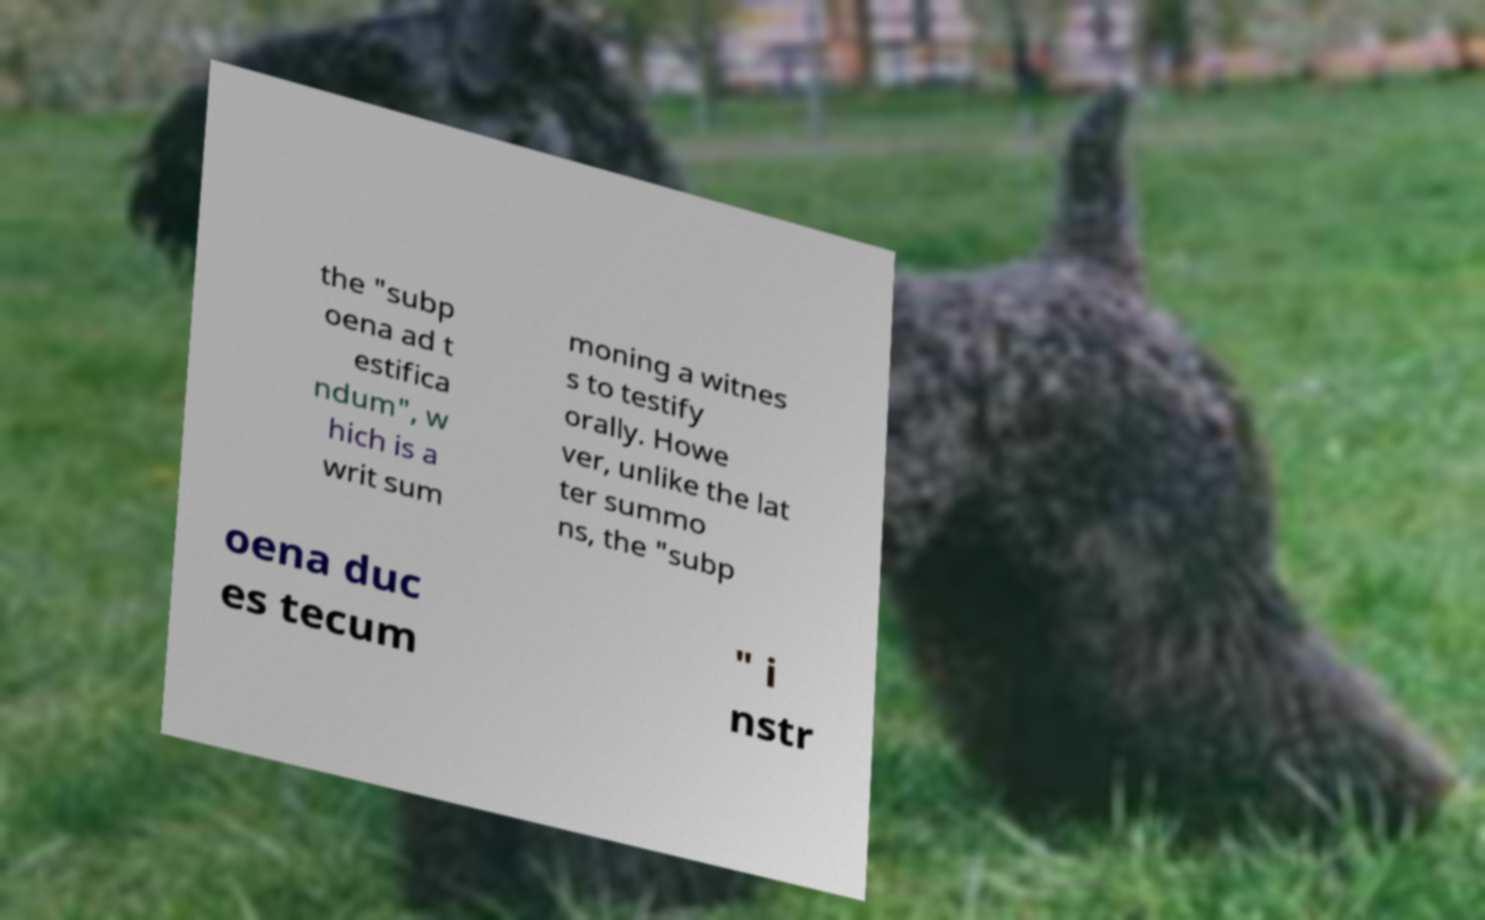What messages or text are displayed in this image? I need them in a readable, typed format. the "subp oena ad t estifica ndum", w hich is a writ sum moning a witnes s to testify orally. Howe ver, unlike the lat ter summo ns, the "subp oena duc es tecum " i nstr 